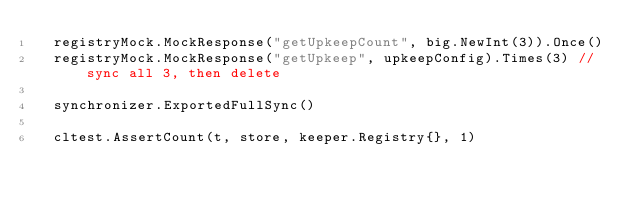Convert code to text. <code><loc_0><loc_0><loc_500><loc_500><_Go_>	registryMock.MockResponse("getUpkeepCount", big.NewInt(3)).Once()
	registryMock.MockResponse("getUpkeep", upkeepConfig).Times(3) // sync all 3, then delete

	synchronizer.ExportedFullSync()

	cltest.AssertCount(t, store, keeper.Registry{}, 1)</code> 